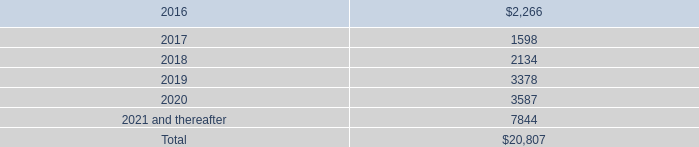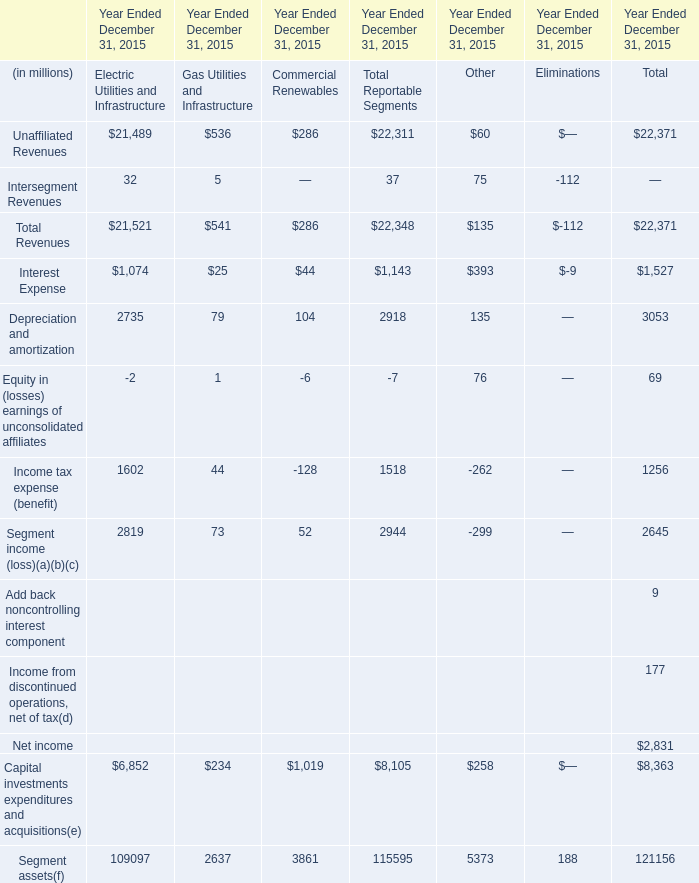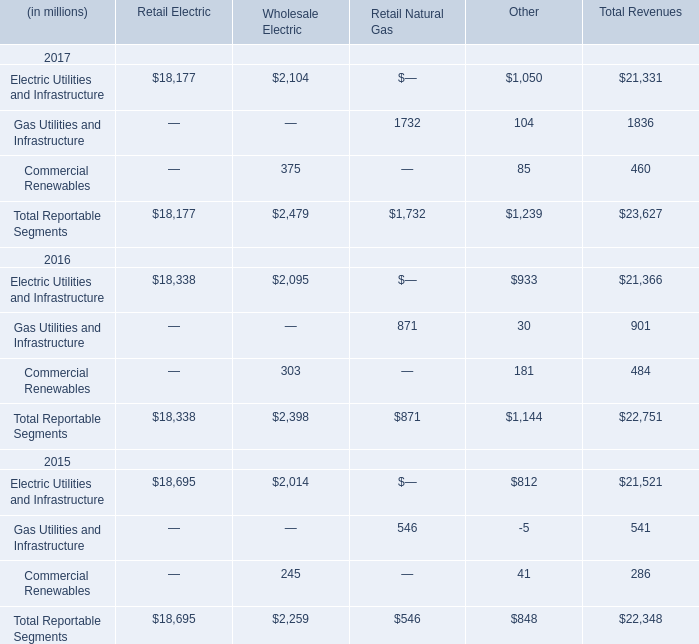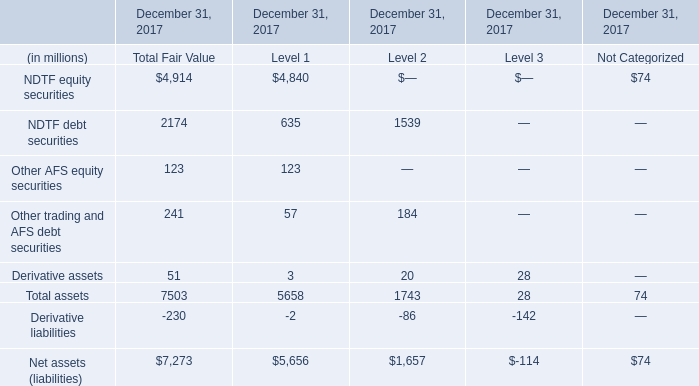What's the average of Electric Utilities and Infrastructure of Other, and NDTF debt securities of December 31, 2017 Level 2 ? 
Computations: ((1050.0 + 1539.0) / 2)
Answer: 1294.5. 